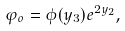<formula> <loc_0><loc_0><loc_500><loc_500>\varphi _ { o } = \phi ( y _ { 3 } ) e ^ { 2 y _ { 2 } } ,</formula> 